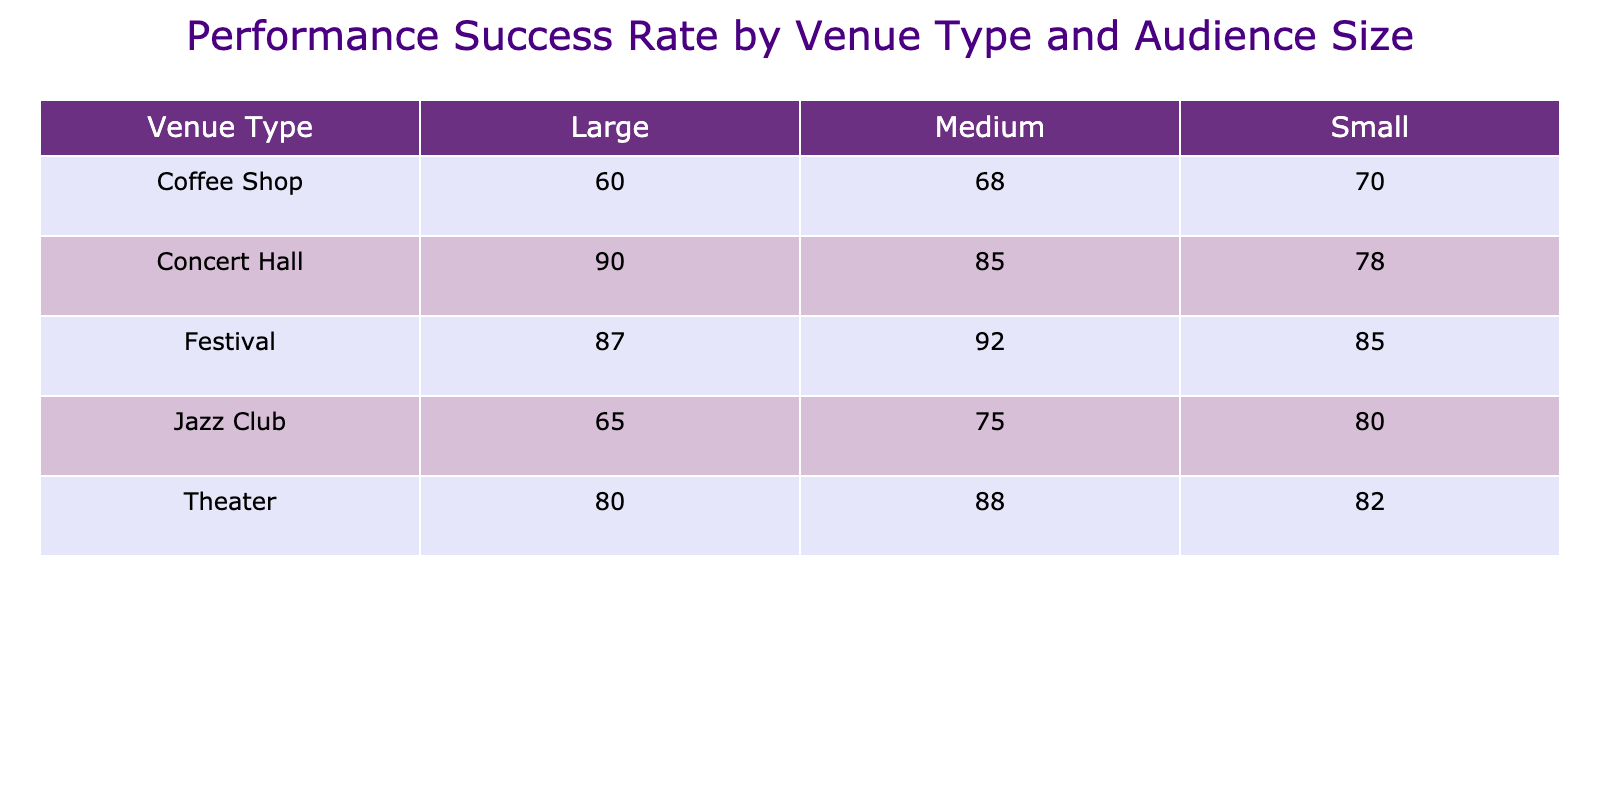What is the performance success rate of pianists in a concert hall with a large audience? According to the table, the performance success rate for a concert hall with a large audience size is 90.
Answer: 90 Which venue type has the lowest performance success rate for small audiences? Looking at the table, the coffee shop has the lowest performance success rate of 70 among the venue types when the audience size is small.
Answer: Coffee Shop What is the average performance success rate for jazz clubs? The performance success rates for jazz clubs are 80, 75, and 65 for small, medium, and large audiences respectively. Calculating the average: (80 + 75 + 65) / 3 = 220 / 3 ≈ 73.33.
Answer: 73.33 Is the performance success rate of festivals higher than that of theaters for medium-sized audiences? The performance success rate for festivals with medium audiences is 92, while for theaters it is 88. Since 92 is greater than 88, the answer is yes.
Answer: Yes What is the difference in performance success rates between large audiences at concert halls and coffee shops? For concert halls, the performance success rate for large audiences is 90, and for coffee shops, it is 60. The difference is 90 - 60 = 30.
Answer: 30 What venue type has a higher performance success rate: theater or festival for small audiences? The performance success rate for theaters with small audiences is 82, and for festivals, it is 85. Since 85 is greater than 82, festivals have a higher success rate.
Answer: Festival What is the maximum performance success rate among all venue types for medium audiences? Looking through the table, the highest performance success rate for medium audiences is found in festivals with a rate of 92. No other venue type exceeds this rate.
Answer: 92 Is there any venue type where the performance success rate decreases as the audience size increases? For coffee shops, the performance success rates decrease from 70 (small) to 68 (medium) to 60 (large). This indicates a decline in performance success rate with increasing audience size in this venue type.
Answer: Yes What is the total performance success rate for large audiences across all venue types? The performance success rates for large audiences are 90 (concert hall) + 65 (jazz club) + 60 (coffee shop) + 80 (theater) + 87 (festival). The total is 90 + 65 + 60 + 80 + 87 = 382.
Answer: 382 